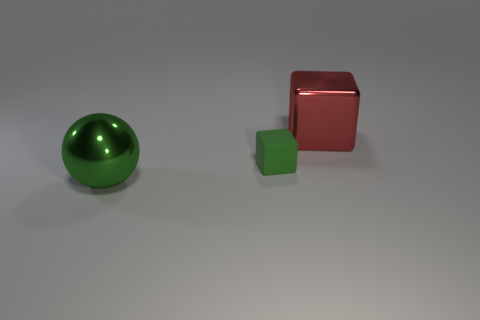Add 3 red cubes. How many objects exist? 6 Subtract all spheres. How many objects are left? 2 Subtract 0 yellow cylinders. How many objects are left? 3 Subtract all big rubber cubes. Subtract all red things. How many objects are left? 2 Add 3 large green shiny spheres. How many large green shiny spheres are left? 4 Add 1 gray metal balls. How many gray metal balls exist? 1 